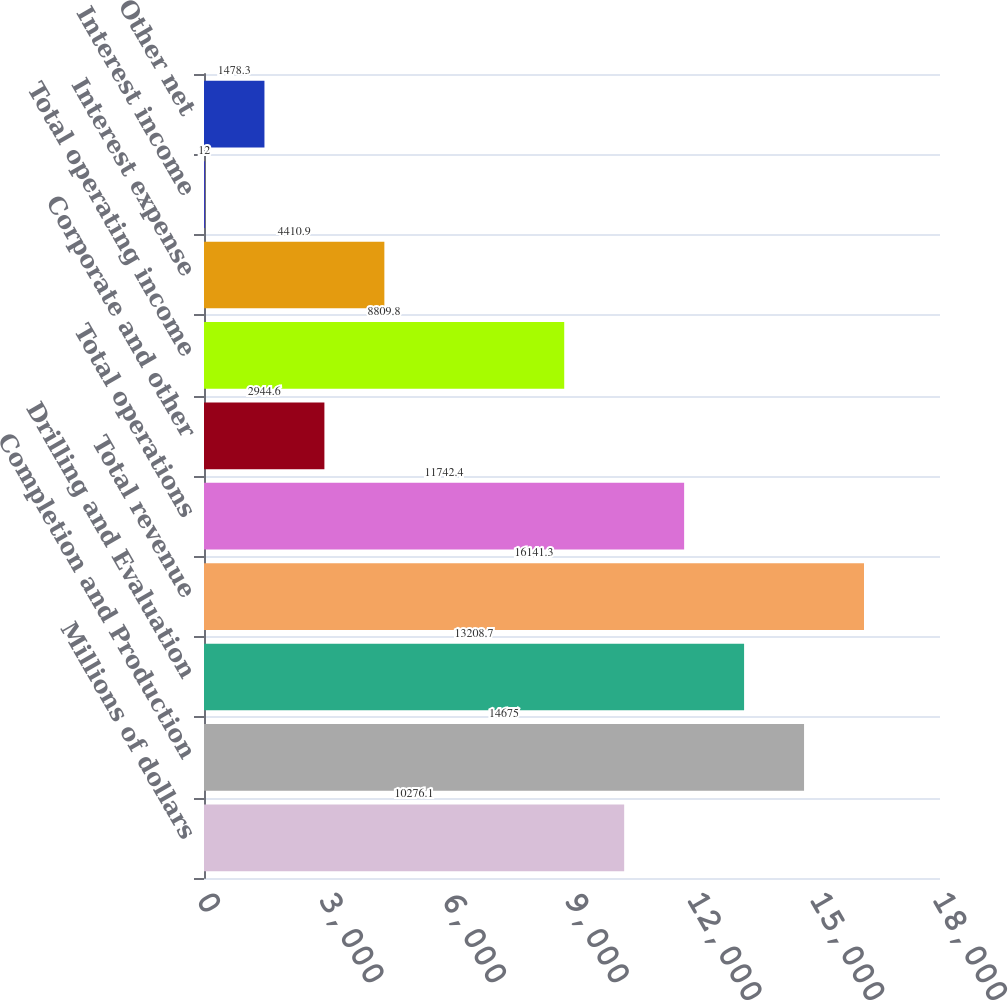Convert chart. <chart><loc_0><loc_0><loc_500><loc_500><bar_chart><fcel>Millions of dollars<fcel>Completion and Production<fcel>Drilling and Evaluation<fcel>Total revenue<fcel>Total operations<fcel>Corporate and other<fcel>Total operating income<fcel>Interest expense<fcel>Interest income<fcel>Other net<nl><fcel>10276.1<fcel>14675<fcel>13208.7<fcel>16141.3<fcel>11742.4<fcel>2944.6<fcel>8809.8<fcel>4410.9<fcel>12<fcel>1478.3<nl></chart> 